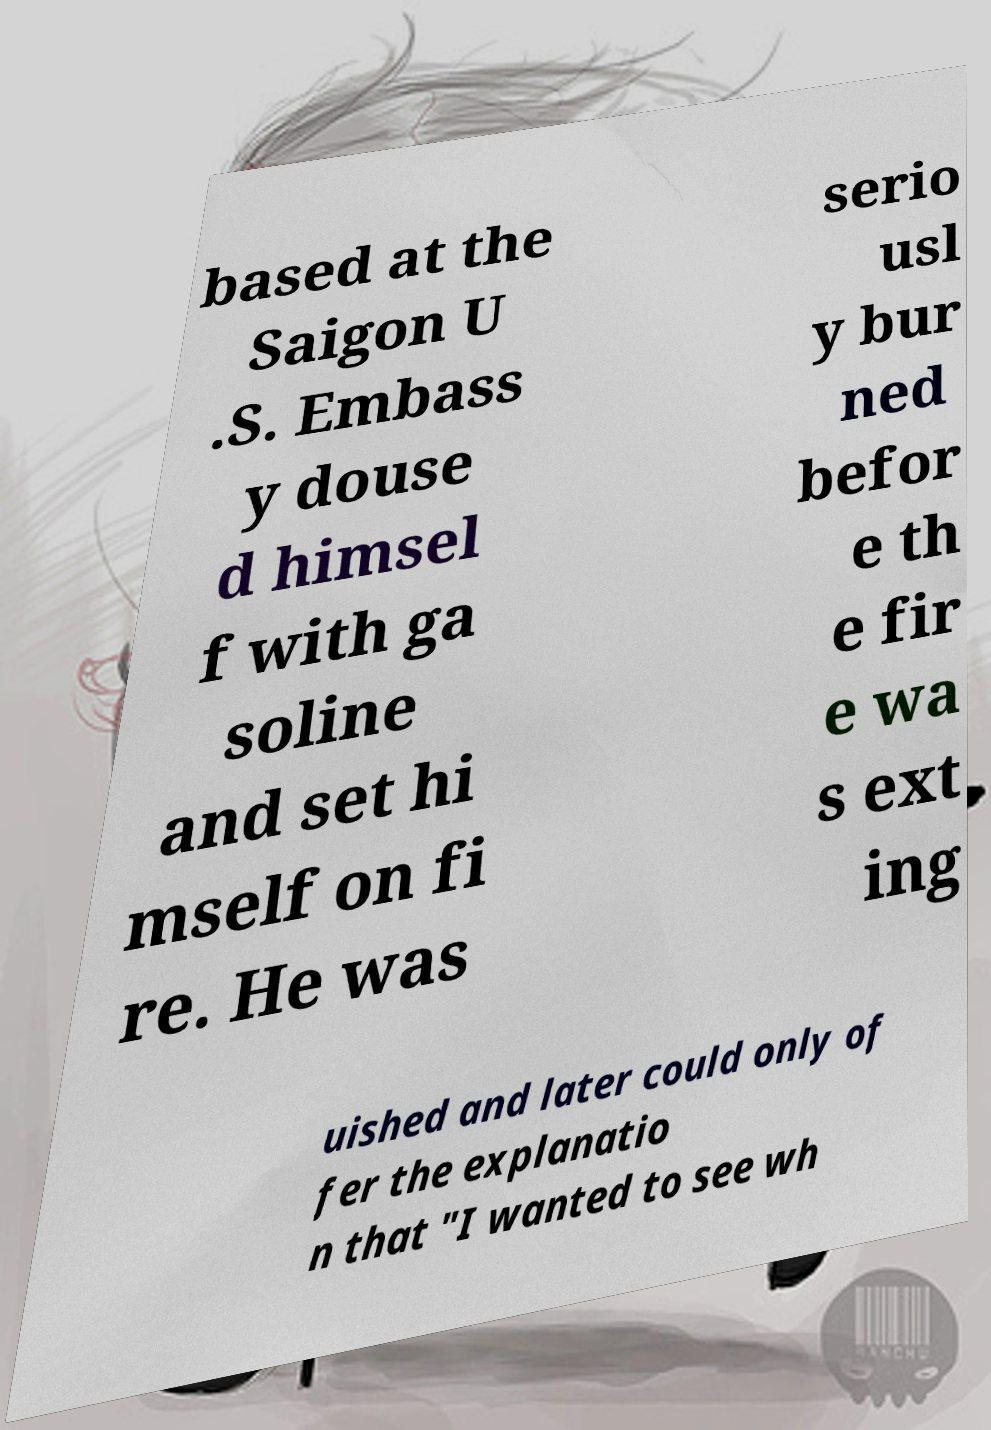There's text embedded in this image that I need extracted. Can you transcribe it verbatim? based at the Saigon U .S. Embass y douse d himsel f with ga soline and set hi mself on fi re. He was serio usl y bur ned befor e th e fir e wa s ext ing uished and later could only of fer the explanatio n that "I wanted to see wh 